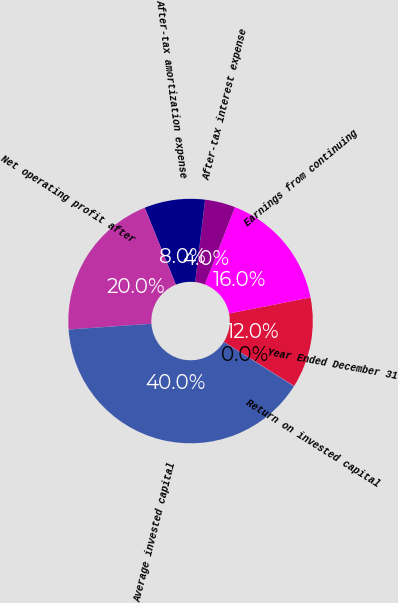Convert chart to OTSL. <chart><loc_0><loc_0><loc_500><loc_500><pie_chart><fcel>Year Ended December 31<fcel>Earnings from continuing<fcel>After-tax interest expense<fcel>After-tax amortization expense<fcel>Net operating profit after<fcel>Average invested capital<fcel>Return on invested capital<nl><fcel>12.0%<fcel>16.0%<fcel>4.02%<fcel>8.01%<fcel>19.99%<fcel>39.95%<fcel>0.03%<nl></chart> 